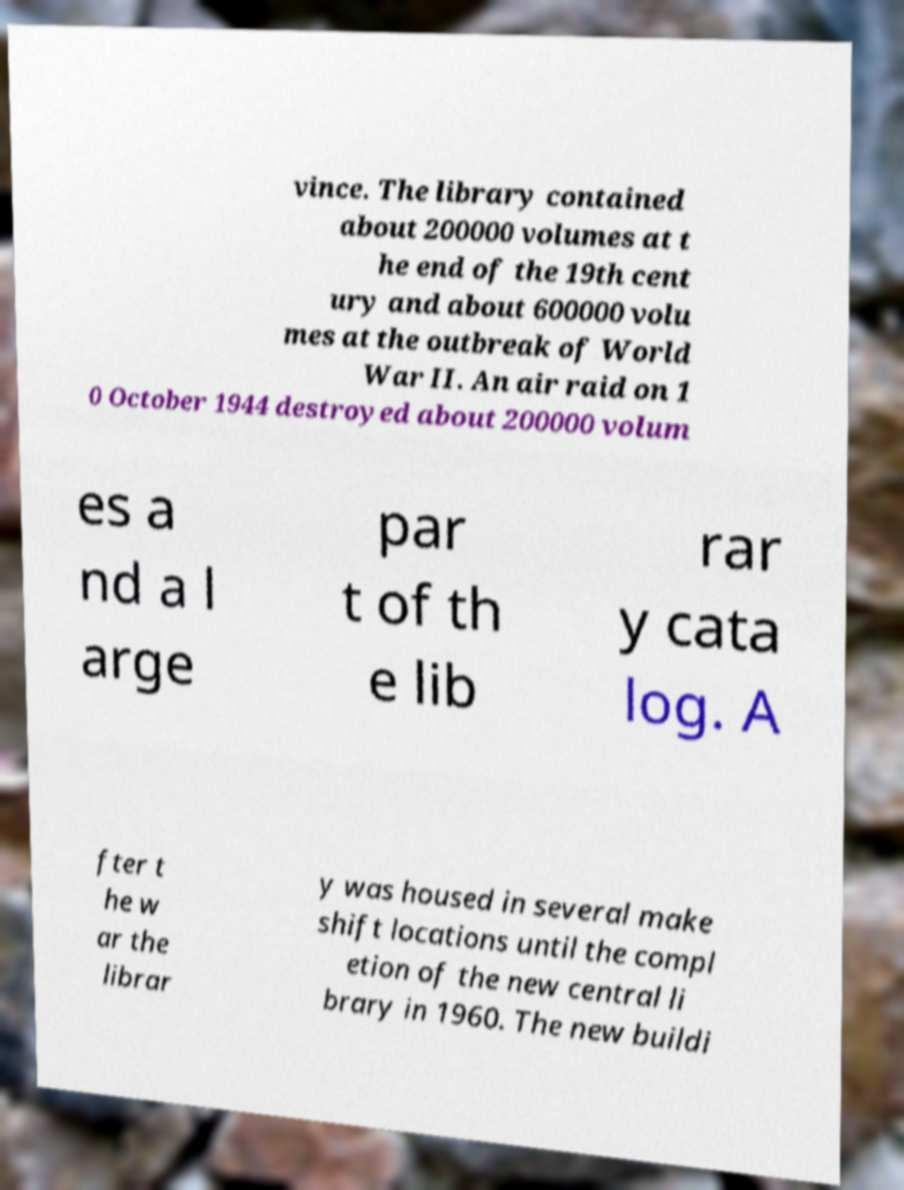Please identify and transcribe the text found in this image. vince. The library contained about 200000 volumes at t he end of the 19th cent ury and about 600000 volu mes at the outbreak of World War II. An air raid on 1 0 October 1944 destroyed about 200000 volum es a nd a l arge par t of th e lib rar y cata log. A fter t he w ar the librar y was housed in several make shift locations until the compl etion of the new central li brary in 1960. The new buildi 